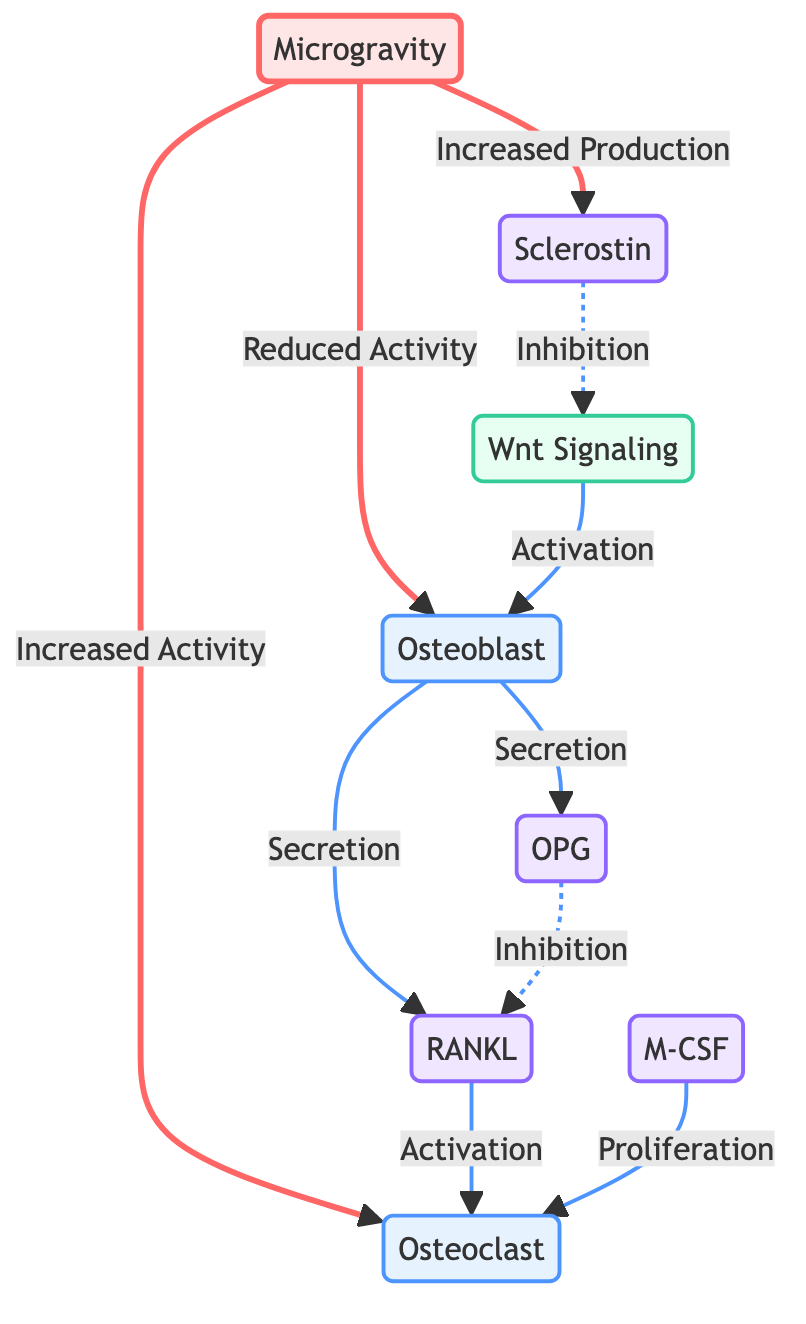What is the impact of microgravity on osteoblast activity? The diagram shows that microgravity leads to "Reduced Activity" of osteoblasts. This relationship is directly indicated by the arrow coming from the microgravity node pointing towards the osteoblast node labeled "Reduced Activity."
Answer: Reduced Activity How does RANKL affect osteoclasts? According to the diagram, RANKL is indicated to cause "Activation" of osteoclasts. This is shown by the directed arrow from RANKL to Osteoclast with the label "Activation."
Answer: Activation What is the role of OPG in this diagram? The diagram indicates that OPG is secreted by osteoblasts and has an "Inhibition" effect on RANKL, as shown by the dashed line pointing from OPG to RANKL, indicating a regulatory role in preventing its activity.
Answer: Inhibition of RANKL How many proteins are illustrated in the diagram? By examining the diagram, there are four protein nodes: RANKL, OPG, M-CSF, and Sclerostin. Counting these nodes gives a total of four proteins represented in the structure.
Answer: 4 What cellular activity is increased in microgravity according to the diagram? The diagram indicates that microgravity results in "Increased Activity" of osteoclasts, as shown by the arrow moving from the microgravity node to the osteoclast node marked "Increased Activity."
Answer: Increased Activity How does Sclerostin affect Wnt signaling? The diagram illustrates that Sclerostin has an "Inhibition" effect on Wnt signaling, indicated by the dashed line connecting Sclerostin to Wnt Signaling and labeled "Inhibition."
Answer: Inhibition What does M-CSF promote in the context of the diagram? It is shown that M-CSF promotes the "Proliferation" of osteoclasts. This is indicated by the directed arrow from M-CSF to Osteoclast labeled "Proliferation."
Answer: Proliferation Which process increases due to microgravity's impact on osteoblasts? The diagram displays that due to microgravity's impact, osteoblasts increase the "Secretion" of RANKL, which is noted by the directed arrow leading from osteoblasts to RANKL with the label "Secretion."
Answer: Secretion of RANKL 